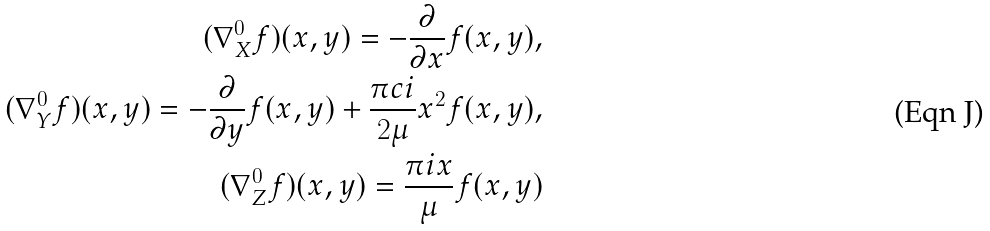Convert formula to latex. <formula><loc_0><loc_0><loc_500><loc_500>( \nabla ^ { 0 } _ { X } f ) ( x , y ) = - \frac { \partial } { \partial x } f ( x , y ) , \\ ( \nabla ^ { 0 } _ { Y } f ) ( x , y ) = - \frac { \partial } { \partial y } f ( x , y ) + \frac { \pi c i } { 2 \mu } x ^ { 2 } f ( x , y ) , \\ ( \nabla ^ { 0 } _ { Z } f ) ( x , y ) = \frac { \pi i x } { \mu } f ( x , y )</formula> 